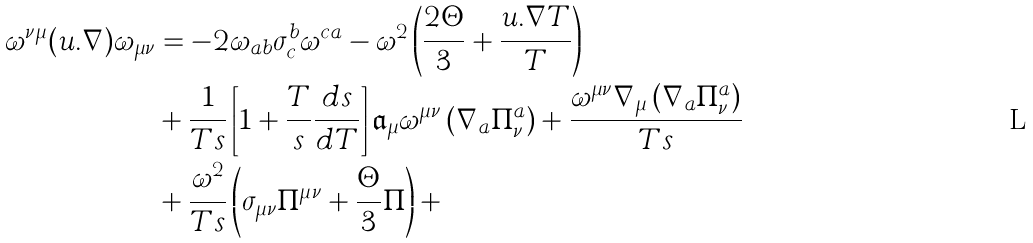<formula> <loc_0><loc_0><loc_500><loc_500>\omega ^ { \nu \mu } ( u . \nabla ) \omega _ { \mu \nu } & = - 2 \omega _ { a b } \sigma ^ { b } _ { c } \omega ^ { c a } - \omega ^ { 2 } \left ( \frac { 2 \Theta } { 3 } + \frac { u . \nabla T } { T } \right ) \\ & + \frac { 1 } { T s } \left [ 1 + \frac { T } { s } \frac { d s } { d T } \right ] { \mathfrak a } _ { \mu } \omega ^ { \mu \nu } \left ( \nabla _ { a } \Pi ^ { a } _ { \nu } \right ) + \frac { \omega ^ { \mu \nu } \nabla _ { \mu } \left ( \nabla _ { a } \Pi ^ { a } _ { \nu } \right ) } { T s } \\ & + \frac { \omega ^ { 2 } } { T s } \left ( \sigma _ { \mu \nu } \Pi ^ { \mu \nu } + \frac { \Theta } { 3 } \Pi \right ) + \cdots</formula> 